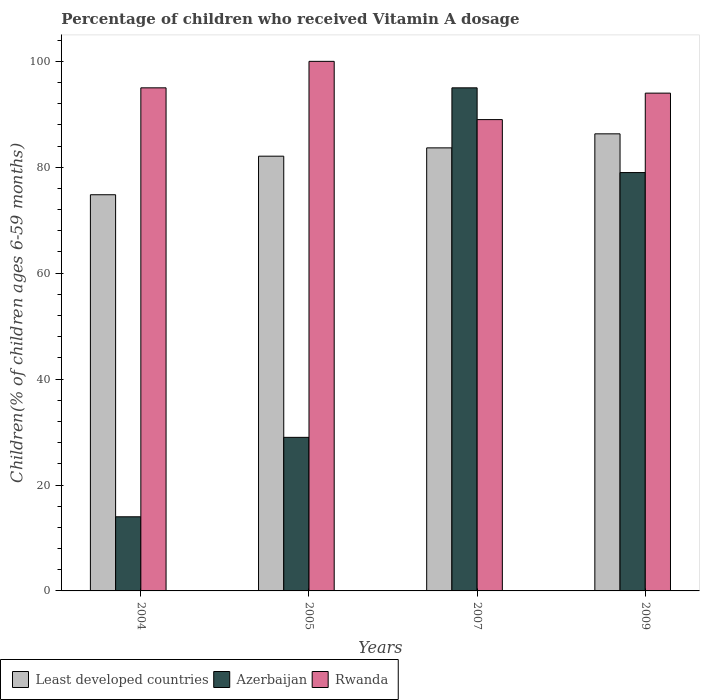How many bars are there on the 1st tick from the left?
Your answer should be compact. 3. What is the label of the 2nd group of bars from the left?
Make the answer very short. 2005. What is the percentage of children who received Vitamin A dosage in Least developed countries in 2005?
Your answer should be compact. 82.1. Across all years, what is the maximum percentage of children who received Vitamin A dosage in Azerbaijan?
Give a very brief answer. 95. Across all years, what is the minimum percentage of children who received Vitamin A dosage in Least developed countries?
Make the answer very short. 74.81. In which year was the percentage of children who received Vitamin A dosage in Azerbaijan maximum?
Your answer should be very brief. 2007. In which year was the percentage of children who received Vitamin A dosage in Least developed countries minimum?
Offer a very short reply. 2004. What is the total percentage of children who received Vitamin A dosage in Rwanda in the graph?
Your answer should be compact. 378. What is the difference between the percentage of children who received Vitamin A dosage in Least developed countries in 2005 and that in 2007?
Your answer should be very brief. -1.57. What is the difference between the percentage of children who received Vitamin A dosage in Least developed countries in 2005 and the percentage of children who received Vitamin A dosage in Rwanda in 2004?
Make the answer very short. -12.9. What is the average percentage of children who received Vitamin A dosage in Rwanda per year?
Give a very brief answer. 94.5. In the year 2009, what is the difference between the percentage of children who received Vitamin A dosage in Least developed countries and percentage of children who received Vitamin A dosage in Rwanda?
Provide a short and direct response. -7.69. What is the ratio of the percentage of children who received Vitamin A dosage in Least developed countries in 2005 to that in 2007?
Provide a succinct answer. 0.98. Is the percentage of children who received Vitamin A dosage in Least developed countries in 2005 less than that in 2009?
Offer a terse response. Yes. What is the difference between the highest and the second highest percentage of children who received Vitamin A dosage in Least developed countries?
Keep it short and to the point. 2.65. What is the difference between the highest and the lowest percentage of children who received Vitamin A dosage in Least developed countries?
Your answer should be very brief. 11.5. What does the 1st bar from the left in 2009 represents?
Your answer should be very brief. Least developed countries. What does the 3rd bar from the right in 2004 represents?
Offer a terse response. Least developed countries. Is it the case that in every year, the sum of the percentage of children who received Vitamin A dosage in Rwanda and percentage of children who received Vitamin A dosage in Least developed countries is greater than the percentage of children who received Vitamin A dosage in Azerbaijan?
Offer a very short reply. Yes. Does the graph contain any zero values?
Keep it short and to the point. No. Does the graph contain grids?
Offer a terse response. No. Where does the legend appear in the graph?
Keep it short and to the point. Bottom left. How many legend labels are there?
Keep it short and to the point. 3. What is the title of the graph?
Ensure brevity in your answer.  Percentage of children who received Vitamin A dosage. What is the label or title of the X-axis?
Ensure brevity in your answer.  Years. What is the label or title of the Y-axis?
Provide a short and direct response. Children(% of children ages 6-59 months). What is the Children(% of children ages 6-59 months) in Least developed countries in 2004?
Offer a very short reply. 74.81. What is the Children(% of children ages 6-59 months) in Rwanda in 2004?
Make the answer very short. 95. What is the Children(% of children ages 6-59 months) of Least developed countries in 2005?
Provide a succinct answer. 82.1. What is the Children(% of children ages 6-59 months) of Least developed countries in 2007?
Your answer should be compact. 83.66. What is the Children(% of children ages 6-59 months) in Rwanda in 2007?
Your answer should be compact. 89. What is the Children(% of children ages 6-59 months) of Least developed countries in 2009?
Make the answer very short. 86.31. What is the Children(% of children ages 6-59 months) of Azerbaijan in 2009?
Make the answer very short. 79. What is the Children(% of children ages 6-59 months) of Rwanda in 2009?
Make the answer very short. 94. Across all years, what is the maximum Children(% of children ages 6-59 months) in Least developed countries?
Offer a terse response. 86.31. Across all years, what is the minimum Children(% of children ages 6-59 months) in Least developed countries?
Offer a very short reply. 74.81. Across all years, what is the minimum Children(% of children ages 6-59 months) of Rwanda?
Keep it short and to the point. 89. What is the total Children(% of children ages 6-59 months) of Least developed countries in the graph?
Your answer should be very brief. 326.88. What is the total Children(% of children ages 6-59 months) in Azerbaijan in the graph?
Your answer should be compact. 217. What is the total Children(% of children ages 6-59 months) in Rwanda in the graph?
Offer a very short reply. 378. What is the difference between the Children(% of children ages 6-59 months) in Least developed countries in 2004 and that in 2005?
Provide a succinct answer. -7.28. What is the difference between the Children(% of children ages 6-59 months) in Rwanda in 2004 and that in 2005?
Your response must be concise. -5. What is the difference between the Children(% of children ages 6-59 months) in Least developed countries in 2004 and that in 2007?
Your answer should be compact. -8.85. What is the difference between the Children(% of children ages 6-59 months) of Azerbaijan in 2004 and that in 2007?
Provide a short and direct response. -81. What is the difference between the Children(% of children ages 6-59 months) of Least developed countries in 2004 and that in 2009?
Provide a succinct answer. -11.5. What is the difference between the Children(% of children ages 6-59 months) of Azerbaijan in 2004 and that in 2009?
Provide a short and direct response. -65. What is the difference between the Children(% of children ages 6-59 months) of Least developed countries in 2005 and that in 2007?
Offer a very short reply. -1.57. What is the difference between the Children(% of children ages 6-59 months) in Azerbaijan in 2005 and that in 2007?
Your response must be concise. -66. What is the difference between the Children(% of children ages 6-59 months) of Least developed countries in 2005 and that in 2009?
Your answer should be very brief. -4.22. What is the difference between the Children(% of children ages 6-59 months) in Azerbaijan in 2005 and that in 2009?
Provide a succinct answer. -50. What is the difference between the Children(% of children ages 6-59 months) in Rwanda in 2005 and that in 2009?
Offer a terse response. 6. What is the difference between the Children(% of children ages 6-59 months) in Least developed countries in 2007 and that in 2009?
Your answer should be very brief. -2.65. What is the difference between the Children(% of children ages 6-59 months) of Least developed countries in 2004 and the Children(% of children ages 6-59 months) of Azerbaijan in 2005?
Your answer should be very brief. 45.81. What is the difference between the Children(% of children ages 6-59 months) in Least developed countries in 2004 and the Children(% of children ages 6-59 months) in Rwanda in 2005?
Ensure brevity in your answer.  -25.19. What is the difference between the Children(% of children ages 6-59 months) of Azerbaijan in 2004 and the Children(% of children ages 6-59 months) of Rwanda in 2005?
Offer a terse response. -86. What is the difference between the Children(% of children ages 6-59 months) of Least developed countries in 2004 and the Children(% of children ages 6-59 months) of Azerbaijan in 2007?
Your response must be concise. -20.19. What is the difference between the Children(% of children ages 6-59 months) of Least developed countries in 2004 and the Children(% of children ages 6-59 months) of Rwanda in 2007?
Offer a terse response. -14.19. What is the difference between the Children(% of children ages 6-59 months) in Azerbaijan in 2004 and the Children(% of children ages 6-59 months) in Rwanda in 2007?
Make the answer very short. -75. What is the difference between the Children(% of children ages 6-59 months) in Least developed countries in 2004 and the Children(% of children ages 6-59 months) in Azerbaijan in 2009?
Make the answer very short. -4.19. What is the difference between the Children(% of children ages 6-59 months) of Least developed countries in 2004 and the Children(% of children ages 6-59 months) of Rwanda in 2009?
Provide a succinct answer. -19.19. What is the difference between the Children(% of children ages 6-59 months) in Azerbaijan in 2004 and the Children(% of children ages 6-59 months) in Rwanda in 2009?
Your answer should be very brief. -80. What is the difference between the Children(% of children ages 6-59 months) in Least developed countries in 2005 and the Children(% of children ages 6-59 months) in Azerbaijan in 2007?
Your response must be concise. -12.9. What is the difference between the Children(% of children ages 6-59 months) of Least developed countries in 2005 and the Children(% of children ages 6-59 months) of Rwanda in 2007?
Provide a short and direct response. -6.91. What is the difference between the Children(% of children ages 6-59 months) in Azerbaijan in 2005 and the Children(% of children ages 6-59 months) in Rwanda in 2007?
Provide a short and direct response. -60. What is the difference between the Children(% of children ages 6-59 months) of Least developed countries in 2005 and the Children(% of children ages 6-59 months) of Azerbaijan in 2009?
Keep it short and to the point. 3.1. What is the difference between the Children(% of children ages 6-59 months) in Least developed countries in 2005 and the Children(% of children ages 6-59 months) in Rwanda in 2009?
Your response must be concise. -11.9. What is the difference between the Children(% of children ages 6-59 months) of Azerbaijan in 2005 and the Children(% of children ages 6-59 months) of Rwanda in 2009?
Give a very brief answer. -65. What is the difference between the Children(% of children ages 6-59 months) of Least developed countries in 2007 and the Children(% of children ages 6-59 months) of Azerbaijan in 2009?
Provide a succinct answer. 4.66. What is the difference between the Children(% of children ages 6-59 months) in Least developed countries in 2007 and the Children(% of children ages 6-59 months) in Rwanda in 2009?
Provide a succinct answer. -10.34. What is the average Children(% of children ages 6-59 months) of Least developed countries per year?
Provide a succinct answer. 81.72. What is the average Children(% of children ages 6-59 months) of Azerbaijan per year?
Provide a short and direct response. 54.25. What is the average Children(% of children ages 6-59 months) of Rwanda per year?
Provide a succinct answer. 94.5. In the year 2004, what is the difference between the Children(% of children ages 6-59 months) of Least developed countries and Children(% of children ages 6-59 months) of Azerbaijan?
Offer a very short reply. 60.81. In the year 2004, what is the difference between the Children(% of children ages 6-59 months) in Least developed countries and Children(% of children ages 6-59 months) in Rwanda?
Ensure brevity in your answer.  -20.19. In the year 2004, what is the difference between the Children(% of children ages 6-59 months) of Azerbaijan and Children(% of children ages 6-59 months) of Rwanda?
Your answer should be very brief. -81. In the year 2005, what is the difference between the Children(% of children ages 6-59 months) of Least developed countries and Children(% of children ages 6-59 months) of Azerbaijan?
Ensure brevity in your answer.  53.09. In the year 2005, what is the difference between the Children(% of children ages 6-59 months) in Least developed countries and Children(% of children ages 6-59 months) in Rwanda?
Provide a short and direct response. -17.91. In the year 2005, what is the difference between the Children(% of children ages 6-59 months) in Azerbaijan and Children(% of children ages 6-59 months) in Rwanda?
Offer a very short reply. -71. In the year 2007, what is the difference between the Children(% of children ages 6-59 months) in Least developed countries and Children(% of children ages 6-59 months) in Azerbaijan?
Offer a very short reply. -11.34. In the year 2007, what is the difference between the Children(% of children ages 6-59 months) in Least developed countries and Children(% of children ages 6-59 months) in Rwanda?
Provide a short and direct response. -5.34. In the year 2007, what is the difference between the Children(% of children ages 6-59 months) in Azerbaijan and Children(% of children ages 6-59 months) in Rwanda?
Your answer should be very brief. 6. In the year 2009, what is the difference between the Children(% of children ages 6-59 months) of Least developed countries and Children(% of children ages 6-59 months) of Azerbaijan?
Provide a short and direct response. 7.31. In the year 2009, what is the difference between the Children(% of children ages 6-59 months) of Least developed countries and Children(% of children ages 6-59 months) of Rwanda?
Keep it short and to the point. -7.69. What is the ratio of the Children(% of children ages 6-59 months) of Least developed countries in 2004 to that in 2005?
Keep it short and to the point. 0.91. What is the ratio of the Children(% of children ages 6-59 months) of Azerbaijan in 2004 to that in 2005?
Make the answer very short. 0.48. What is the ratio of the Children(% of children ages 6-59 months) of Least developed countries in 2004 to that in 2007?
Ensure brevity in your answer.  0.89. What is the ratio of the Children(% of children ages 6-59 months) of Azerbaijan in 2004 to that in 2007?
Offer a very short reply. 0.15. What is the ratio of the Children(% of children ages 6-59 months) of Rwanda in 2004 to that in 2007?
Give a very brief answer. 1.07. What is the ratio of the Children(% of children ages 6-59 months) in Least developed countries in 2004 to that in 2009?
Provide a short and direct response. 0.87. What is the ratio of the Children(% of children ages 6-59 months) in Azerbaijan in 2004 to that in 2009?
Give a very brief answer. 0.18. What is the ratio of the Children(% of children ages 6-59 months) in Rwanda in 2004 to that in 2009?
Your answer should be compact. 1.01. What is the ratio of the Children(% of children ages 6-59 months) of Least developed countries in 2005 to that in 2007?
Provide a short and direct response. 0.98. What is the ratio of the Children(% of children ages 6-59 months) of Azerbaijan in 2005 to that in 2007?
Ensure brevity in your answer.  0.31. What is the ratio of the Children(% of children ages 6-59 months) in Rwanda in 2005 to that in 2007?
Offer a very short reply. 1.12. What is the ratio of the Children(% of children ages 6-59 months) in Least developed countries in 2005 to that in 2009?
Provide a short and direct response. 0.95. What is the ratio of the Children(% of children ages 6-59 months) in Azerbaijan in 2005 to that in 2009?
Offer a terse response. 0.37. What is the ratio of the Children(% of children ages 6-59 months) in Rwanda in 2005 to that in 2009?
Make the answer very short. 1.06. What is the ratio of the Children(% of children ages 6-59 months) in Least developed countries in 2007 to that in 2009?
Your answer should be very brief. 0.97. What is the ratio of the Children(% of children ages 6-59 months) in Azerbaijan in 2007 to that in 2009?
Your answer should be very brief. 1.2. What is the ratio of the Children(% of children ages 6-59 months) of Rwanda in 2007 to that in 2009?
Keep it short and to the point. 0.95. What is the difference between the highest and the second highest Children(% of children ages 6-59 months) in Least developed countries?
Provide a succinct answer. 2.65. What is the difference between the highest and the second highest Children(% of children ages 6-59 months) in Azerbaijan?
Your answer should be very brief. 16. What is the difference between the highest and the lowest Children(% of children ages 6-59 months) of Least developed countries?
Your answer should be compact. 11.5. What is the difference between the highest and the lowest Children(% of children ages 6-59 months) of Rwanda?
Ensure brevity in your answer.  11. 